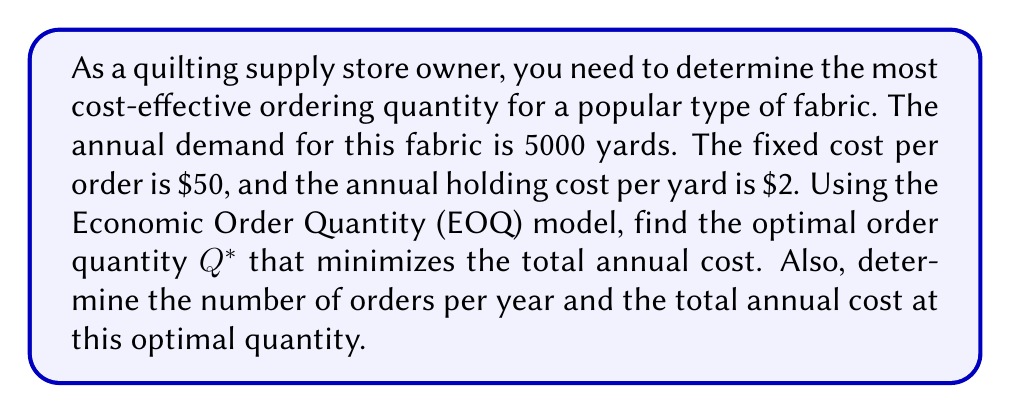Teach me how to tackle this problem. To solve this problem, we'll use the Economic Order Quantity (EOQ) model. Let's define the variables:

$D$ = Annual demand = 5000 yards
$K$ = Fixed cost per order = $50
$h$ = Annual holding cost per unit = $2 per yard

1. The EOQ formula is:

   $$Q^* = \sqrt{\frac{2KD}{h}}$$

2. Substituting the values:

   $$Q^* = \sqrt{\frac{2 \cdot 50 \cdot 5000}{2}} = \sqrt{250000} = 500$$

3. The optimal order quantity is 500 yards.

4. To find the number of orders per year:

   Number of orders = $\frac{D}{Q^*} = \frac{5000}{500} = 10$ orders per year

5. To calculate the total annual cost, we use the formula:

   Total Cost = Order Cost + Holding Cost
   $$TC = \frac{KD}{Q^*} + \frac{hQ^*}{2}$$

6. Substituting the values:

   $$TC = \frac{50 \cdot 5000}{500} + \frac{2 \cdot 500}{2} = 500 + 500 = 1000$$

The total annual cost at the optimal quantity is $1000.
Answer: The optimal order quantity $Q^*$ is 500 yards. The number of orders per year is 10, and the total annual cost at this optimal quantity is $1000. 